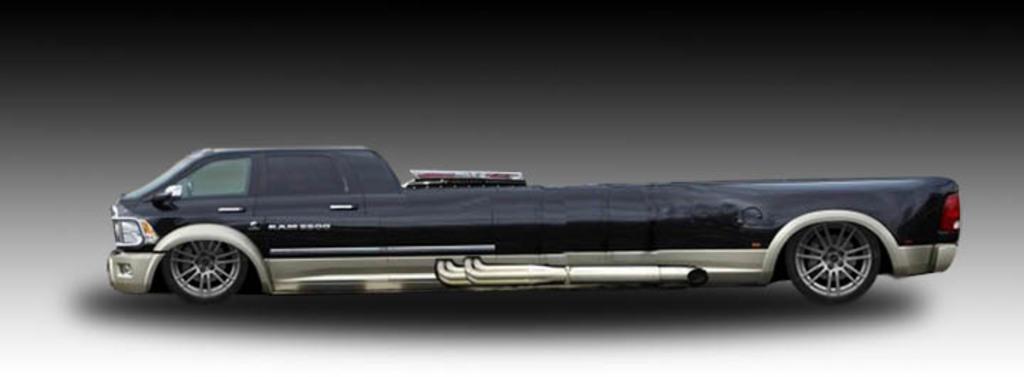Describe this image in one or two sentences. In the image there is a toy of a truck and it is in black color. 